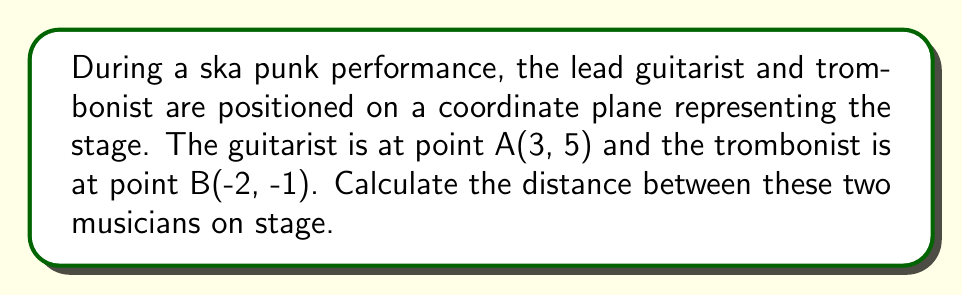Can you solve this math problem? To find the distance between two points on a coordinate plane, we use the distance formula:

$$d = \sqrt{(x_2 - x_1)^2 + (y_2 - y_1)^2}$$

Where $(x_1, y_1)$ represents the coordinates of the first point and $(x_2, y_2)$ represents the coordinates of the second point.

Let's plug in our values:
- Guitarist (Point A): $(x_1, y_1) = (3, 5)$
- Trombonist (Point B): $(x_2, y_2) = (-2, -1)$

Now, let's calculate:

1) $x_2 - x_1 = -2 - 3 = -5$
2) $y_2 - y_1 = -1 - 5 = -6$

Plugging these into our formula:

$$\begin{align}
d &= \sqrt{(-5)^2 + (-6)^2} \\
&= \sqrt{25 + 36} \\
&= \sqrt{61}
\end{align}$$

Therefore, the distance between the guitarist and trombonist is $\sqrt{61}$ units.

[asy]
unitsize(1cm);
dot((3,5),red);
dot((-2,-1),blue);
draw((3,5)--(-2,-1),dashed);
label("A (3,5)", (3,5), NE);
label("B (-2,-1)", (-2,-1), SW);
label("$\sqrt{61}$", (0.5,2), SE);
xaxis(-3,4,Arrow);
yaxis(-2,6,Arrow);
[/asy]
Answer: $\sqrt{61}$ units 